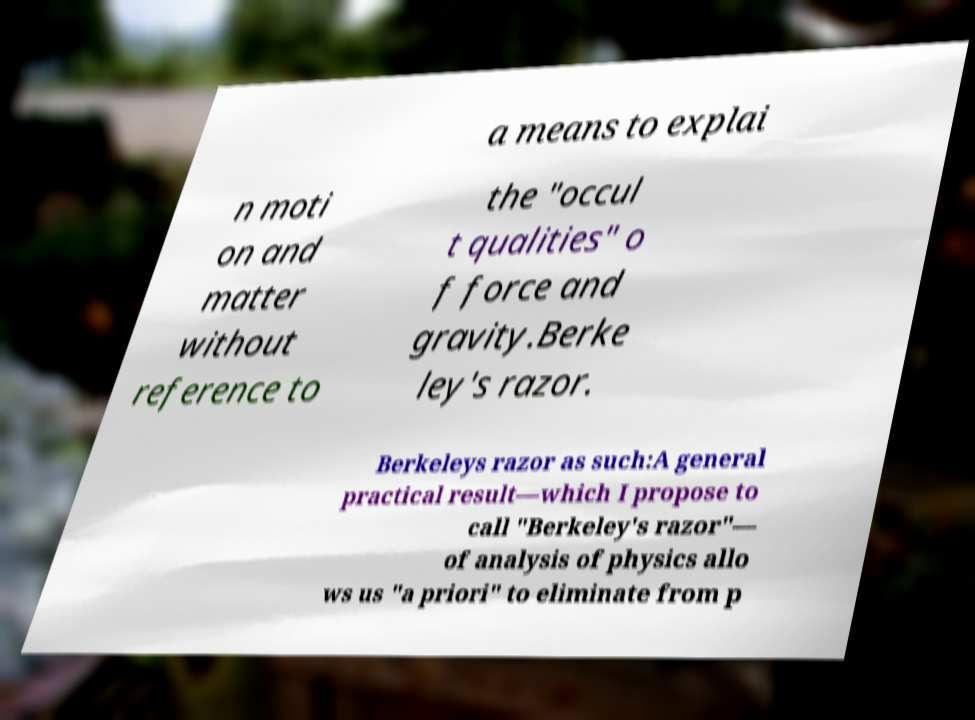For documentation purposes, I need the text within this image transcribed. Could you provide that? a means to explai n moti on and matter without reference to the "occul t qualities" o f force and gravity.Berke ley's razor. Berkeleys razor as such:A general practical result—which I propose to call "Berkeley's razor"— of analysis of physics allo ws us "a priori" to eliminate from p 